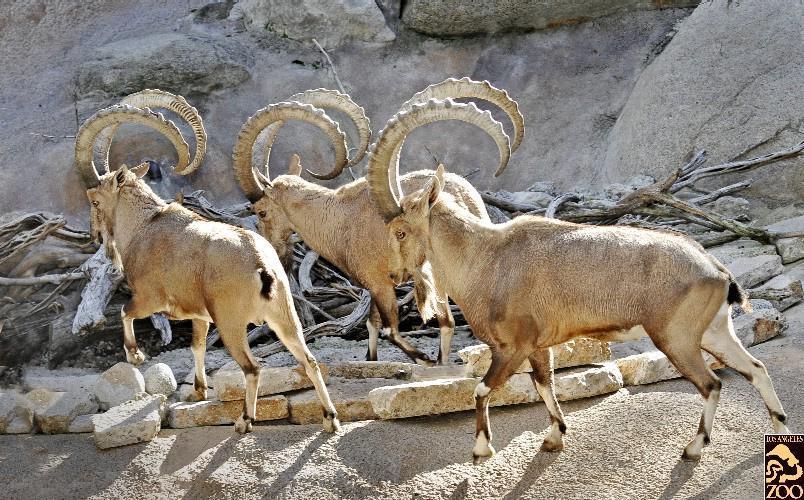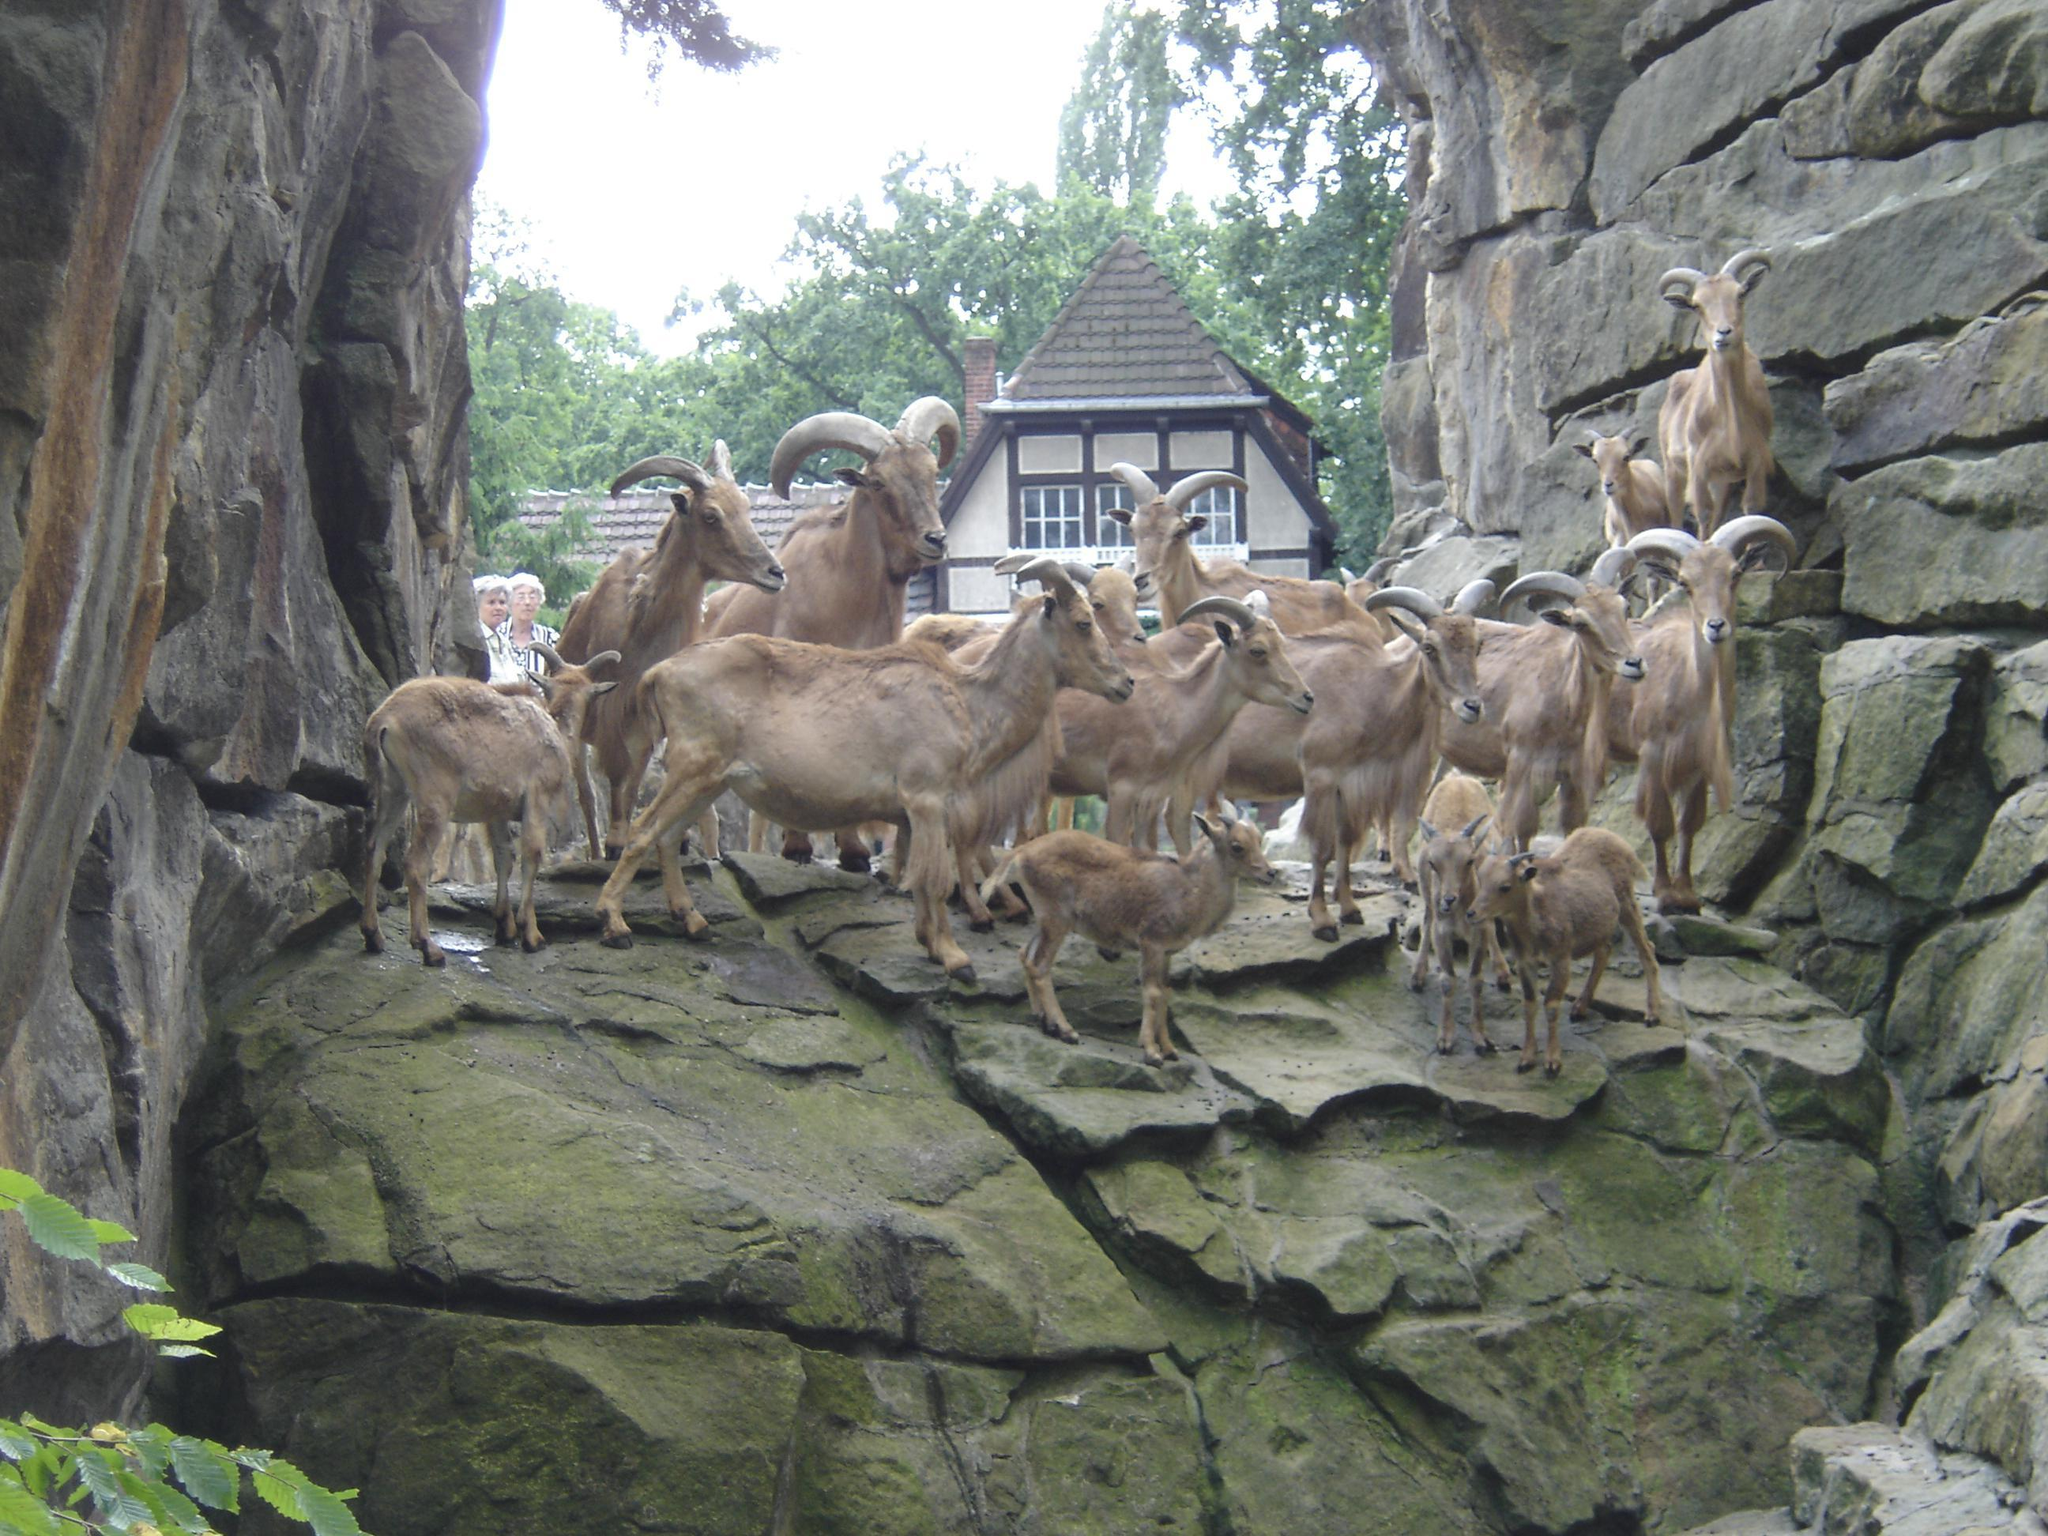The first image is the image on the left, the second image is the image on the right. Examine the images to the left and right. Is the description "An image shows three horned animals on a surface with flat stones arranged in a row." accurate? Answer yes or no. Yes. The first image is the image on the left, the second image is the image on the right. Evaluate the accuracy of this statement regarding the images: "At least one of the animals is standing in a grassy area.". Is it true? Answer yes or no. No. 